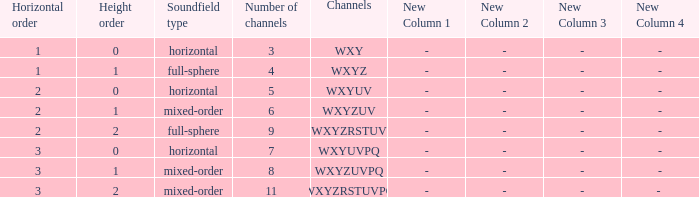If the channels is wxyzrstuvpq, what is the horizontal order? 3.0. 